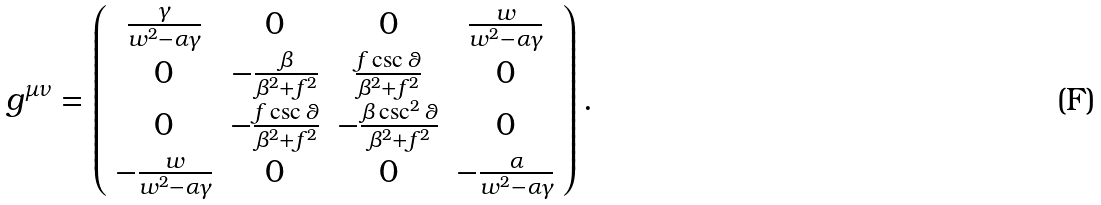Convert formula to latex. <formula><loc_0><loc_0><loc_500><loc_500>g ^ { \mu \nu } = \left ( \begin{array} { c c c c } \frac { \gamma } { w ^ { 2 } - \alpha \gamma } & 0 & 0 & \frac { w } { w ^ { 2 } - \alpha \gamma } \\ 0 & - \frac { \beta } { \beta ^ { 2 } + f ^ { 2 } } & \frac { f \csc \theta } { \beta ^ { 2 } + f ^ { 2 } } & 0 \\ 0 & - \frac { f \csc \theta } { \beta ^ { 2 } + f ^ { 2 } } & - \frac { \beta \csc ^ { 2 } \theta } { \beta ^ { 2 } + f ^ { 2 } } & 0 \\ - \frac { w } { w ^ { 2 } - \alpha \gamma } & 0 & 0 & - \frac { \alpha } { w ^ { 2 } - \alpha \gamma } \\ \end{array} \right ) .</formula> 